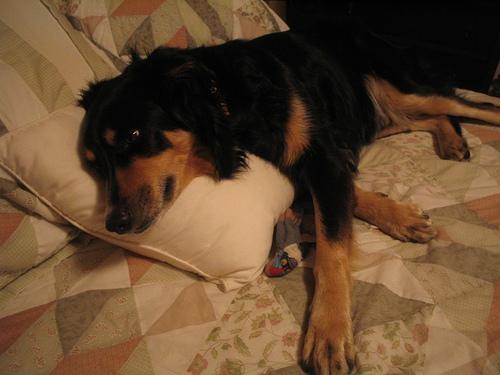What color is the blanket the man is under?
Concise answer only. Multi colored. Is the dog asleep?
Keep it brief. No. Is this dog using a pillow?
Write a very short answer. Yes. What is the design on the pillow?
Be succinct. Solid. Does the dog look healthy?
Answer briefly. Yes. Where is the dog on?
Keep it brief. Bed. 